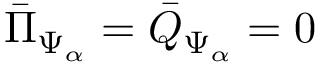<formula> <loc_0><loc_0><loc_500><loc_500>{ \bar { \Pi } } _ { \Psi _ { \alpha } } = { \bar { Q } } _ { \Psi _ { \alpha } } = 0</formula> 